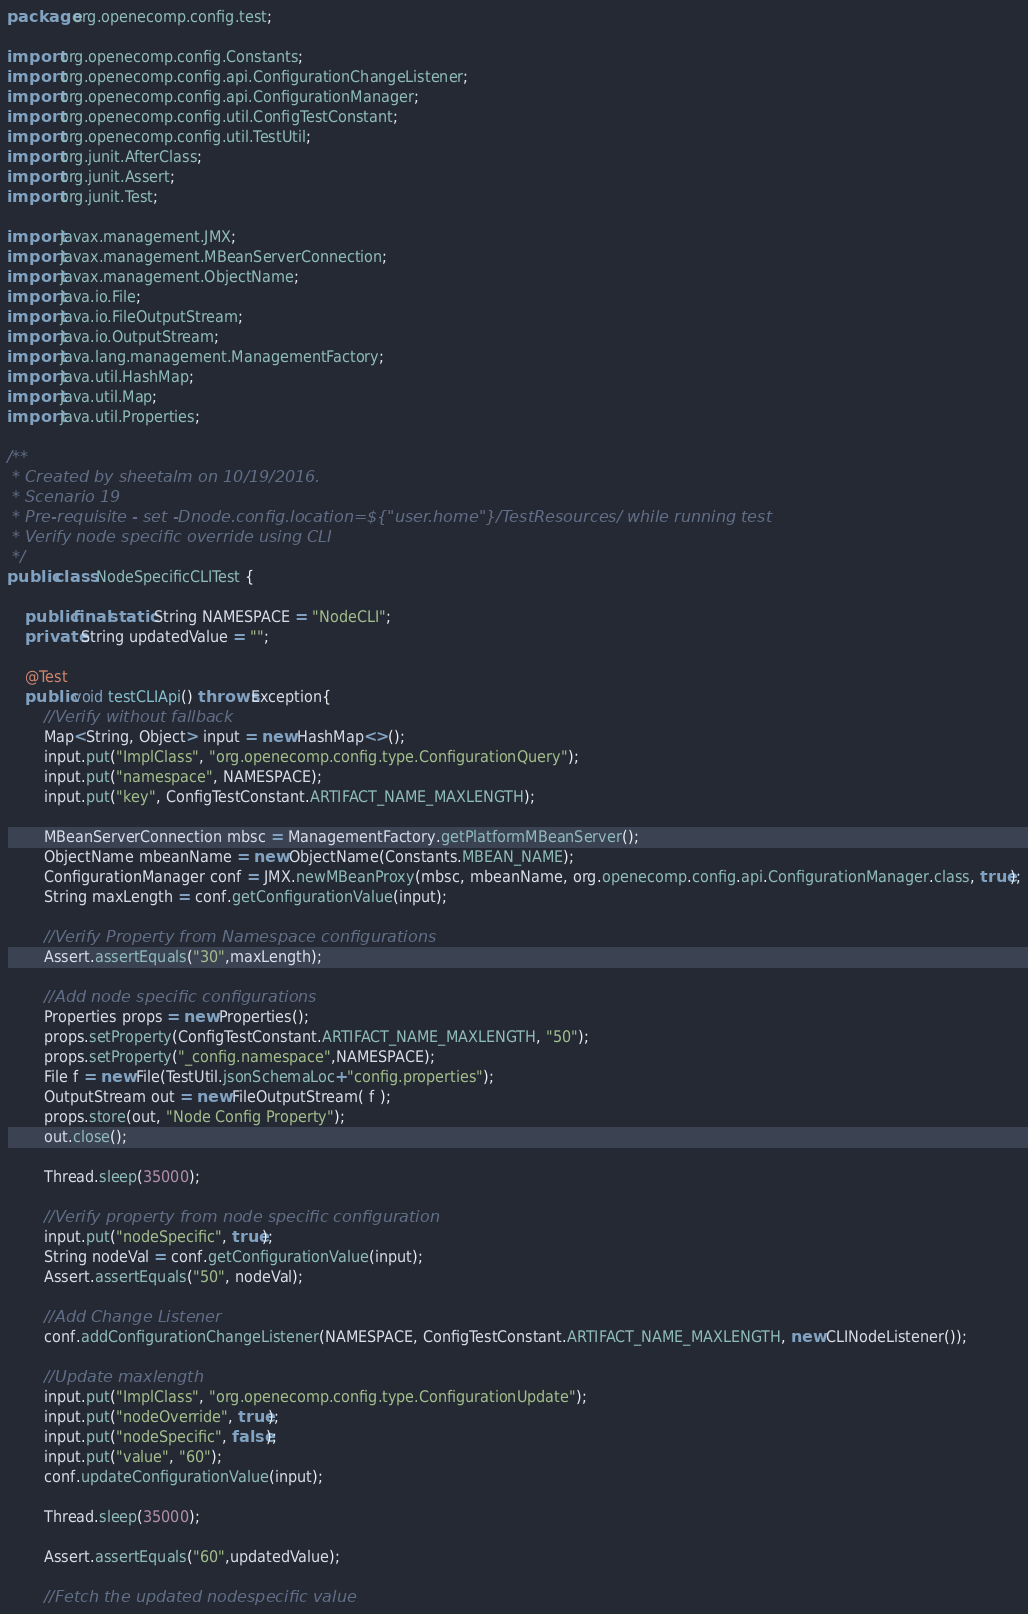Convert code to text. <code><loc_0><loc_0><loc_500><loc_500><_Java_>package org.openecomp.config.test;

import org.openecomp.config.Constants;
import org.openecomp.config.api.ConfigurationChangeListener;
import org.openecomp.config.api.ConfigurationManager;
import org.openecomp.config.util.ConfigTestConstant;
import org.openecomp.config.util.TestUtil;
import org.junit.AfterClass;
import org.junit.Assert;
import org.junit.Test;

import javax.management.JMX;
import javax.management.MBeanServerConnection;
import javax.management.ObjectName;
import java.io.File;
import java.io.FileOutputStream;
import java.io.OutputStream;
import java.lang.management.ManagementFactory;
import java.util.HashMap;
import java.util.Map;
import java.util.Properties;

/**
 * Created by sheetalm on 10/19/2016.
 * Scenario 19
 * Pre-requisite - set -Dnode.config.location=${"user.home"}/TestResources/ while running test
 * Verify node specific override using CLI
 */
public class NodeSpecificCLITest {

    public final static String NAMESPACE = "NodeCLI";
    private String updatedValue = "";

    @Test
    public void testCLIApi() throws Exception{
        //Verify without fallback
        Map<String, Object> input = new HashMap<>();
        input.put("ImplClass", "org.openecomp.config.type.ConfigurationQuery");
        input.put("namespace", NAMESPACE);
        input.put("key", ConfigTestConstant.ARTIFACT_NAME_MAXLENGTH);

        MBeanServerConnection mbsc = ManagementFactory.getPlatformMBeanServer();
        ObjectName mbeanName = new ObjectName(Constants.MBEAN_NAME);
        ConfigurationManager conf = JMX.newMBeanProxy(mbsc, mbeanName, org.openecomp.config.api.ConfigurationManager.class, true);
        String maxLength = conf.getConfigurationValue(input);

        //Verify Property from Namespace configurations
        Assert.assertEquals("30",maxLength);

        //Add node specific configurations
        Properties props = new Properties();
        props.setProperty(ConfigTestConstant.ARTIFACT_NAME_MAXLENGTH, "50");
        props.setProperty("_config.namespace",NAMESPACE);
        File f = new File(TestUtil.jsonSchemaLoc+"config.properties");
        OutputStream out = new FileOutputStream( f );
        props.store(out, "Node Config Property");
        out.close();

        Thread.sleep(35000);

        //Verify property from node specific configuration
        input.put("nodeSpecific", true);
        String nodeVal = conf.getConfigurationValue(input);
        Assert.assertEquals("50", nodeVal);

        //Add Change Listener
        conf.addConfigurationChangeListener(NAMESPACE, ConfigTestConstant.ARTIFACT_NAME_MAXLENGTH, new CLINodeListener());

        //Update maxlength
        input.put("ImplClass", "org.openecomp.config.type.ConfigurationUpdate");
        input.put("nodeOverride", true);
        input.put("nodeSpecific", false);
        input.put("value", "60");
        conf.updateConfigurationValue(input);

        Thread.sleep(35000);

        Assert.assertEquals("60",updatedValue);

        //Fetch the updated nodespecific value</code> 